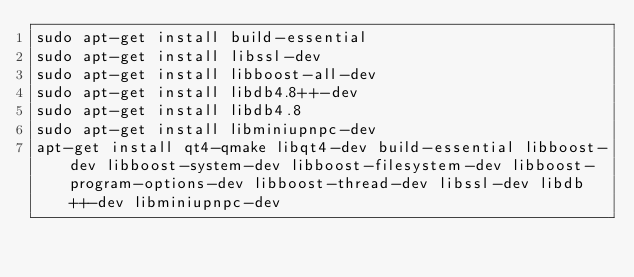Convert code to text. <code><loc_0><loc_0><loc_500><loc_500><_Bash_>sudo apt-get install build-essential
sudo apt-get install libssl-dev
sudo apt-get install libboost-all-dev
sudo apt-get install libdb4.8++-dev
sudo apt-get install libdb4.8
sudo apt-get install libminiupnpc-dev 
apt-get install qt4-qmake libqt4-dev build-essential libboost-dev libboost-system-dev libboost-filesystem-dev libboost-program-options-dev libboost-thread-dev libssl-dev libdb++-dev libminiupnpc-dev</code> 